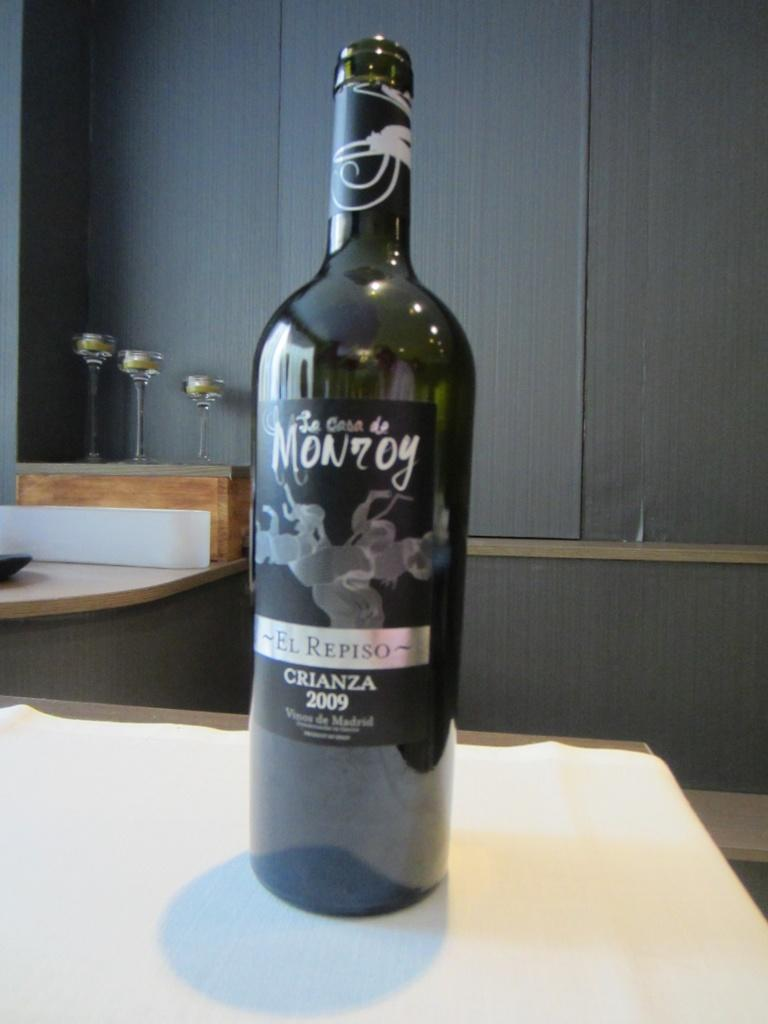<image>
Summarize the visual content of the image. La Casa De Monroy bottle of wine from Madrid sitting on a table. 